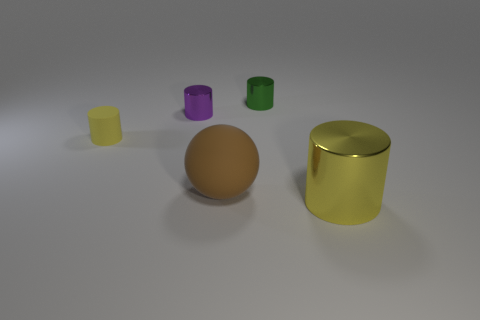Subtract all tiny green cylinders. How many cylinders are left? 3 Add 2 large purple rubber spheres. How many objects exist? 7 Subtract all red spheres. How many yellow cylinders are left? 2 Subtract all purple cylinders. How many cylinders are left? 3 Subtract 1 purple cylinders. How many objects are left? 4 Subtract all cylinders. How many objects are left? 1 Subtract 1 cylinders. How many cylinders are left? 3 Subtract all cyan balls. Subtract all yellow cylinders. How many balls are left? 1 Subtract all tiny purple cylinders. Subtract all big brown things. How many objects are left? 3 Add 5 small purple cylinders. How many small purple cylinders are left? 6 